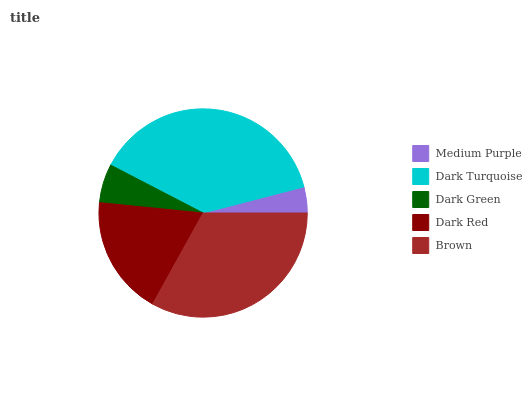Is Medium Purple the minimum?
Answer yes or no. Yes. Is Dark Turquoise the maximum?
Answer yes or no. Yes. Is Dark Green the minimum?
Answer yes or no. No. Is Dark Green the maximum?
Answer yes or no. No. Is Dark Turquoise greater than Dark Green?
Answer yes or no. Yes. Is Dark Green less than Dark Turquoise?
Answer yes or no. Yes. Is Dark Green greater than Dark Turquoise?
Answer yes or no. No. Is Dark Turquoise less than Dark Green?
Answer yes or no. No. Is Dark Red the high median?
Answer yes or no. Yes. Is Dark Red the low median?
Answer yes or no. Yes. Is Medium Purple the high median?
Answer yes or no. No. Is Medium Purple the low median?
Answer yes or no. No. 